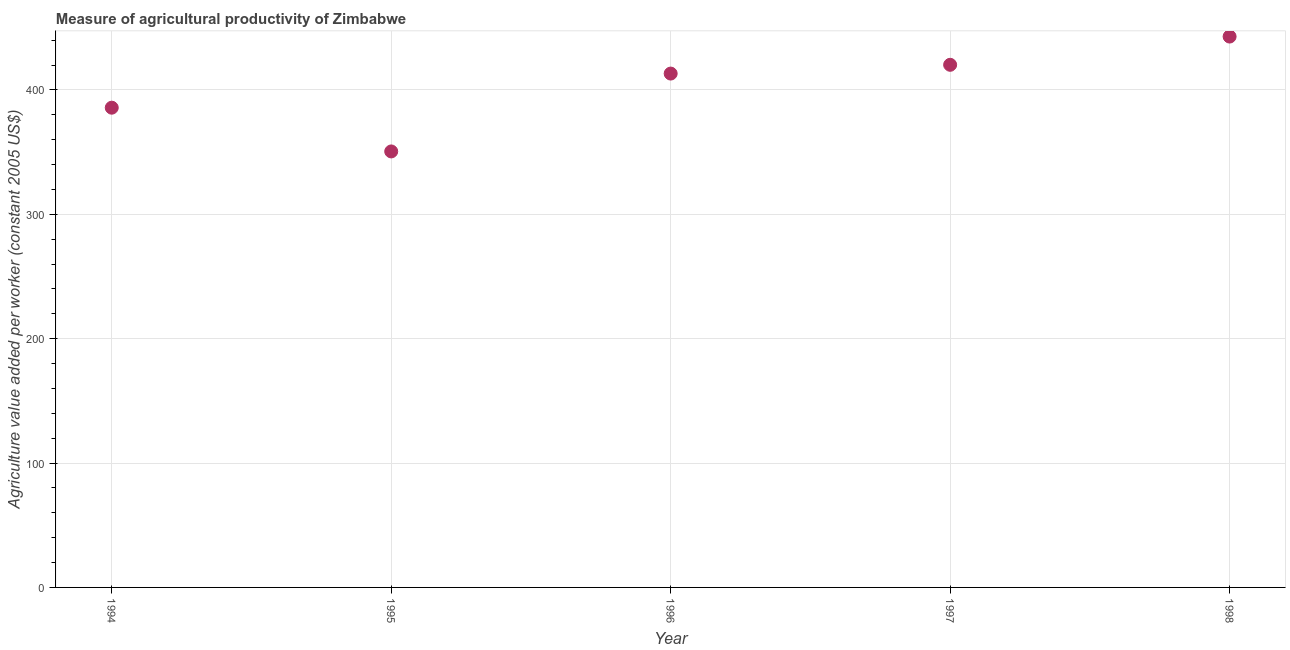What is the agriculture value added per worker in 1998?
Your answer should be compact. 442.87. Across all years, what is the maximum agriculture value added per worker?
Offer a very short reply. 442.87. Across all years, what is the minimum agriculture value added per worker?
Your answer should be very brief. 350.52. In which year was the agriculture value added per worker minimum?
Give a very brief answer. 1995. What is the sum of the agriculture value added per worker?
Offer a very short reply. 2012.39. What is the difference between the agriculture value added per worker in 1994 and 1996?
Your answer should be very brief. -27.43. What is the average agriculture value added per worker per year?
Ensure brevity in your answer.  402.48. What is the median agriculture value added per worker?
Your response must be concise. 413.12. In how many years, is the agriculture value added per worker greater than 60 US$?
Your answer should be very brief. 5. Do a majority of the years between 1995 and 1998 (inclusive) have agriculture value added per worker greater than 220 US$?
Provide a succinct answer. Yes. What is the ratio of the agriculture value added per worker in 1994 to that in 1996?
Provide a short and direct response. 0.93. Is the difference between the agriculture value added per worker in 1995 and 1996 greater than the difference between any two years?
Provide a succinct answer. No. What is the difference between the highest and the second highest agriculture value added per worker?
Your answer should be very brief. 22.7. Is the sum of the agriculture value added per worker in 1996 and 1997 greater than the maximum agriculture value added per worker across all years?
Give a very brief answer. Yes. What is the difference between the highest and the lowest agriculture value added per worker?
Keep it short and to the point. 92.35. Does the agriculture value added per worker monotonically increase over the years?
Your answer should be compact. No. How many dotlines are there?
Your answer should be compact. 1. How many years are there in the graph?
Provide a succinct answer. 5. What is the difference between two consecutive major ticks on the Y-axis?
Make the answer very short. 100. Are the values on the major ticks of Y-axis written in scientific E-notation?
Keep it short and to the point. No. What is the title of the graph?
Offer a very short reply. Measure of agricultural productivity of Zimbabwe. What is the label or title of the Y-axis?
Keep it short and to the point. Agriculture value added per worker (constant 2005 US$). What is the Agriculture value added per worker (constant 2005 US$) in 1994?
Your answer should be compact. 385.7. What is the Agriculture value added per worker (constant 2005 US$) in 1995?
Your answer should be very brief. 350.52. What is the Agriculture value added per worker (constant 2005 US$) in 1996?
Your answer should be very brief. 413.12. What is the Agriculture value added per worker (constant 2005 US$) in 1997?
Offer a very short reply. 420.18. What is the Agriculture value added per worker (constant 2005 US$) in 1998?
Provide a succinct answer. 442.87. What is the difference between the Agriculture value added per worker (constant 2005 US$) in 1994 and 1995?
Your response must be concise. 35.17. What is the difference between the Agriculture value added per worker (constant 2005 US$) in 1994 and 1996?
Provide a short and direct response. -27.43. What is the difference between the Agriculture value added per worker (constant 2005 US$) in 1994 and 1997?
Provide a succinct answer. -34.48. What is the difference between the Agriculture value added per worker (constant 2005 US$) in 1994 and 1998?
Make the answer very short. -57.18. What is the difference between the Agriculture value added per worker (constant 2005 US$) in 1995 and 1996?
Offer a very short reply. -62.6. What is the difference between the Agriculture value added per worker (constant 2005 US$) in 1995 and 1997?
Provide a succinct answer. -69.65. What is the difference between the Agriculture value added per worker (constant 2005 US$) in 1995 and 1998?
Your response must be concise. -92.35. What is the difference between the Agriculture value added per worker (constant 2005 US$) in 1996 and 1997?
Provide a succinct answer. -7.05. What is the difference between the Agriculture value added per worker (constant 2005 US$) in 1996 and 1998?
Make the answer very short. -29.75. What is the difference between the Agriculture value added per worker (constant 2005 US$) in 1997 and 1998?
Offer a terse response. -22.7. What is the ratio of the Agriculture value added per worker (constant 2005 US$) in 1994 to that in 1996?
Provide a succinct answer. 0.93. What is the ratio of the Agriculture value added per worker (constant 2005 US$) in 1994 to that in 1997?
Give a very brief answer. 0.92. What is the ratio of the Agriculture value added per worker (constant 2005 US$) in 1994 to that in 1998?
Keep it short and to the point. 0.87. What is the ratio of the Agriculture value added per worker (constant 2005 US$) in 1995 to that in 1996?
Provide a short and direct response. 0.85. What is the ratio of the Agriculture value added per worker (constant 2005 US$) in 1995 to that in 1997?
Provide a short and direct response. 0.83. What is the ratio of the Agriculture value added per worker (constant 2005 US$) in 1995 to that in 1998?
Ensure brevity in your answer.  0.79. What is the ratio of the Agriculture value added per worker (constant 2005 US$) in 1996 to that in 1997?
Offer a very short reply. 0.98. What is the ratio of the Agriculture value added per worker (constant 2005 US$) in 1996 to that in 1998?
Provide a succinct answer. 0.93. What is the ratio of the Agriculture value added per worker (constant 2005 US$) in 1997 to that in 1998?
Your answer should be compact. 0.95. 